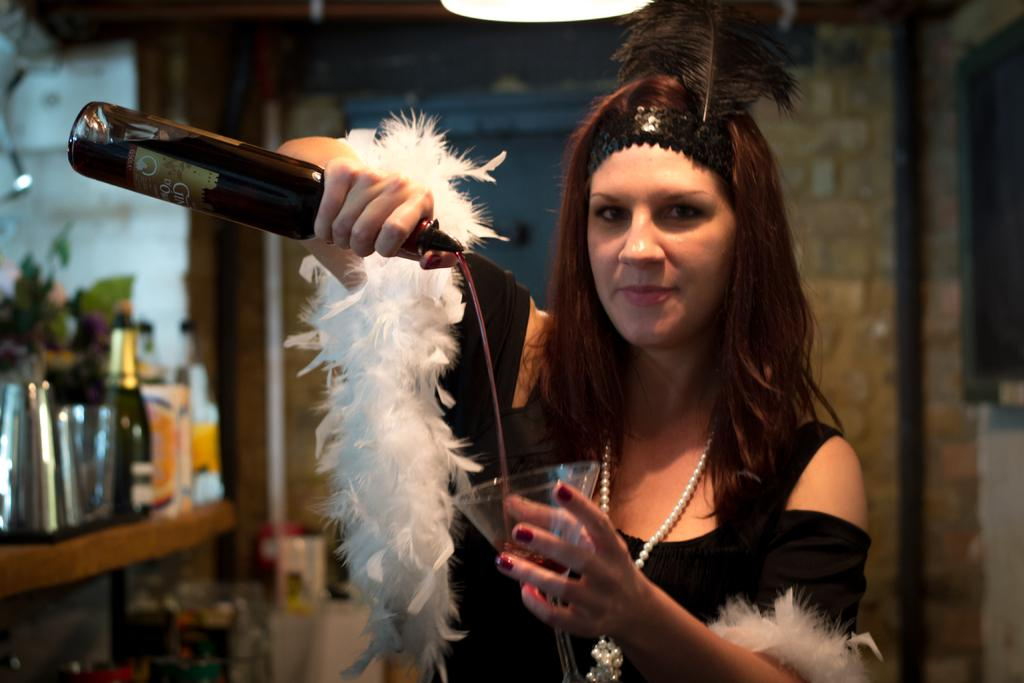Who is the person in the image? There is a woman in the image. What is the woman doing in the image? The woman is pouring juice from a bottle. What is the juice being poured into? The juice is being poured into a glass. What can be seen in the background of the image? There is a wall in the background of the image. How many bottles are visible in the image? There are bottles in the image. What type of leather is the woman using to pour the juice in the image? There is no leather present in the image; the woman is using a bottle to pour the juice. 